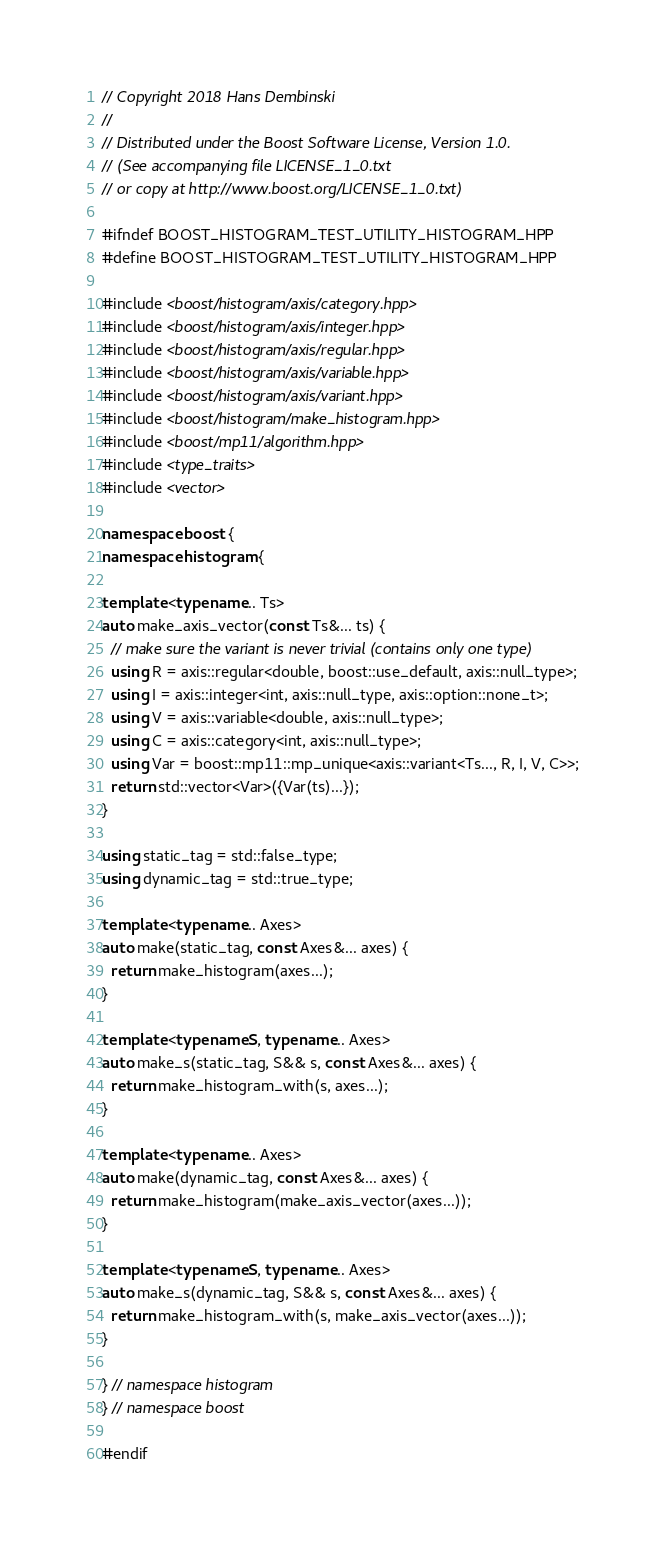<code> <loc_0><loc_0><loc_500><loc_500><_C++_>// Copyright 2018 Hans Dembinski
//
// Distributed under the Boost Software License, Version 1.0.
// (See accompanying file LICENSE_1_0.txt
// or copy at http://www.boost.org/LICENSE_1_0.txt)

#ifndef BOOST_HISTOGRAM_TEST_UTILITY_HISTOGRAM_HPP
#define BOOST_HISTOGRAM_TEST_UTILITY_HISTOGRAM_HPP

#include <boost/histogram/axis/category.hpp>
#include <boost/histogram/axis/integer.hpp>
#include <boost/histogram/axis/regular.hpp>
#include <boost/histogram/axis/variable.hpp>
#include <boost/histogram/axis/variant.hpp>
#include <boost/histogram/make_histogram.hpp>
#include <boost/mp11/algorithm.hpp>
#include <type_traits>
#include <vector>

namespace boost {
namespace histogram {

template <typename... Ts>
auto make_axis_vector(const Ts&... ts) {
  // make sure the variant is never trivial (contains only one type)
  using R = axis::regular<double, boost::use_default, axis::null_type>;
  using I = axis::integer<int, axis::null_type, axis::option::none_t>;
  using V = axis::variable<double, axis::null_type>;
  using C = axis::category<int, axis::null_type>;
  using Var = boost::mp11::mp_unique<axis::variant<Ts..., R, I, V, C>>;
  return std::vector<Var>({Var(ts)...});
}

using static_tag = std::false_type;
using dynamic_tag = std::true_type;

template <typename... Axes>
auto make(static_tag, const Axes&... axes) {
  return make_histogram(axes...);
}

template <typename S, typename... Axes>
auto make_s(static_tag, S&& s, const Axes&... axes) {
  return make_histogram_with(s, axes...);
}

template <typename... Axes>
auto make(dynamic_tag, const Axes&... axes) {
  return make_histogram(make_axis_vector(axes...));
}

template <typename S, typename... Axes>
auto make_s(dynamic_tag, S&& s, const Axes&... axes) {
  return make_histogram_with(s, make_axis_vector(axes...));
}

} // namespace histogram
} // namespace boost

#endif
</code> 